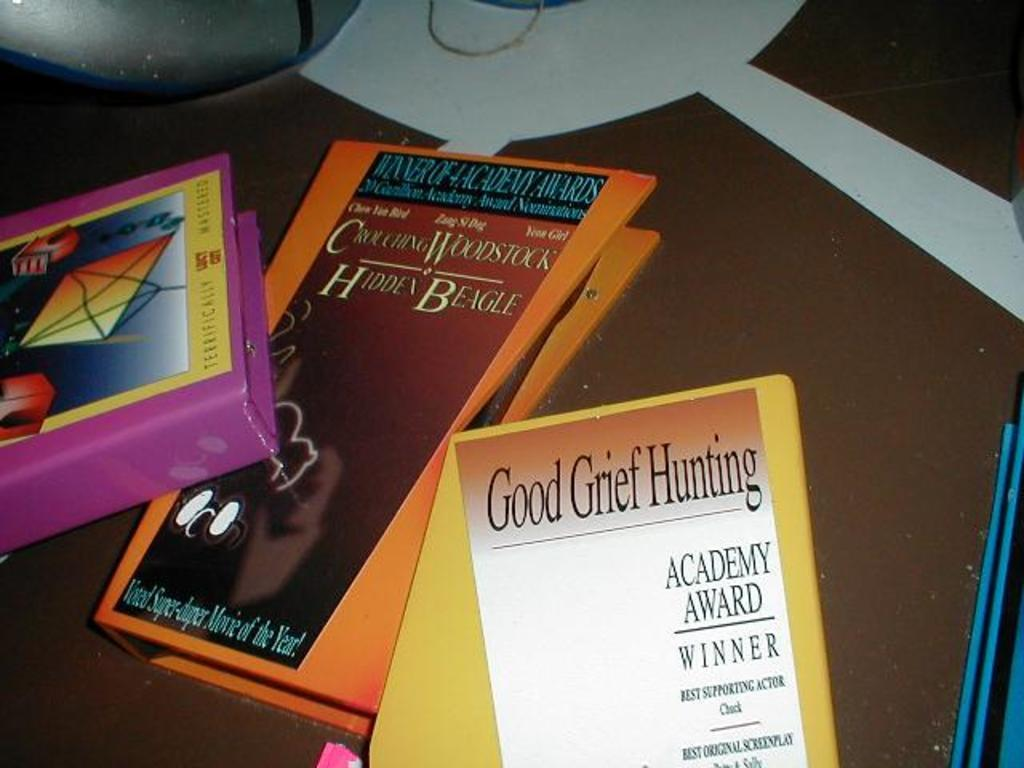<image>
Summarize the visual content of the image. A few books on a table which one is titled Good Grief Hunting. 